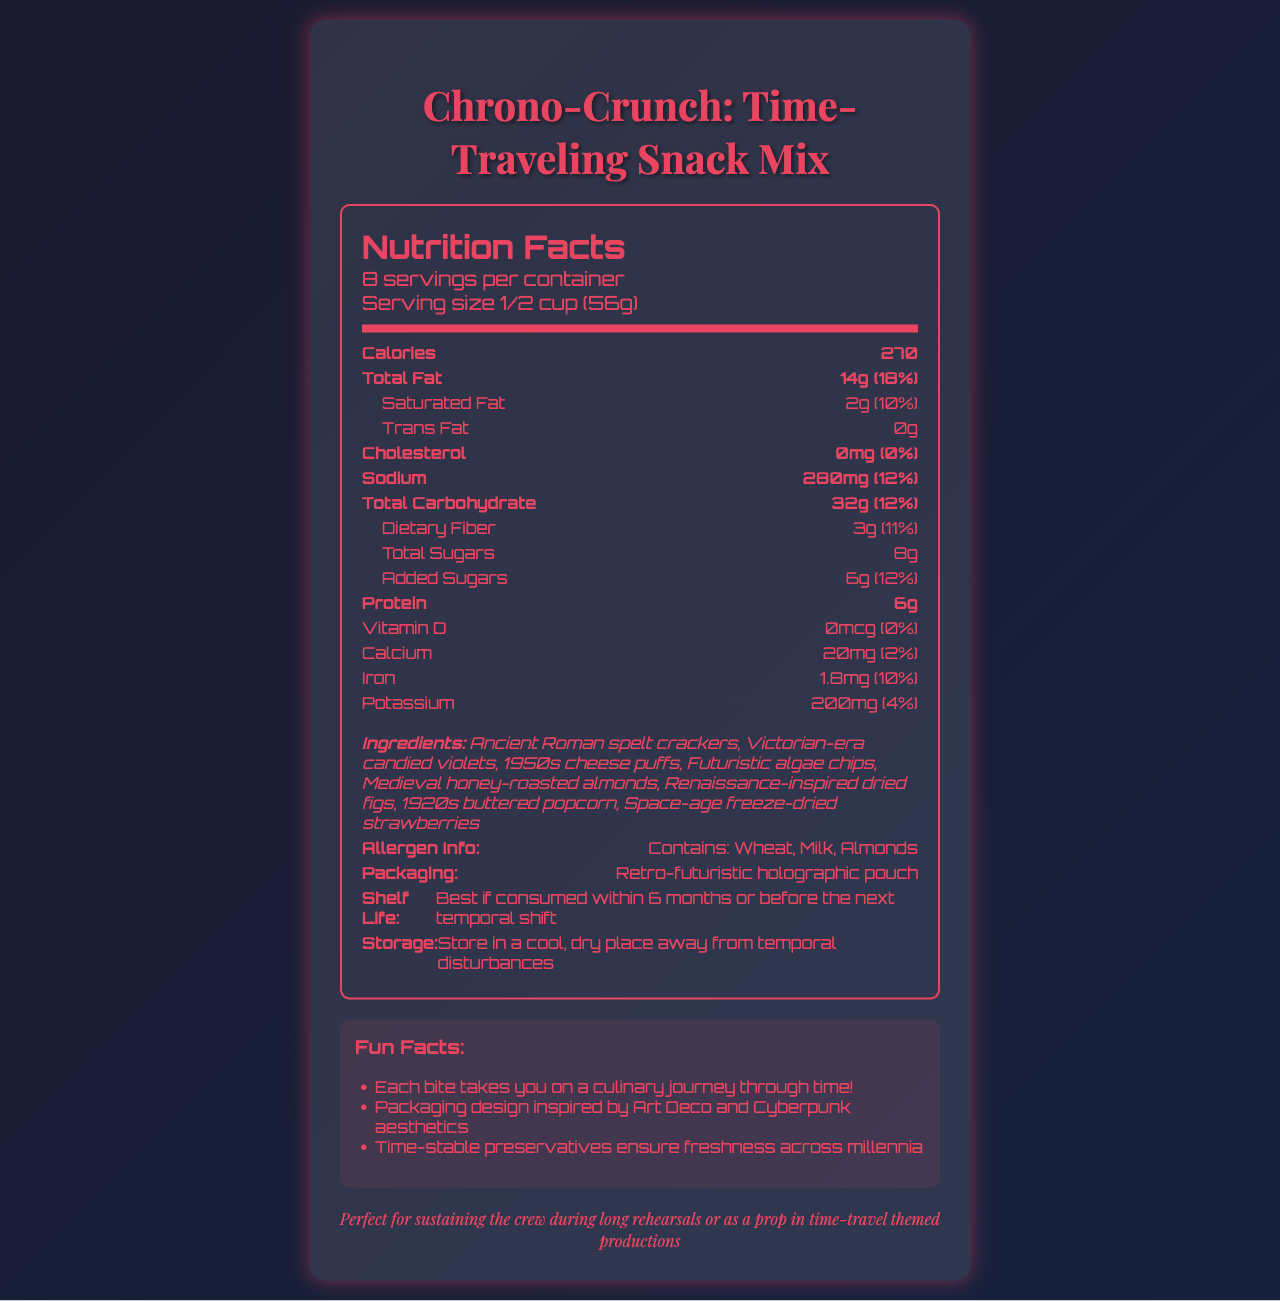what is the serving size? The serving size is explicitly stated in the nutrition label under the serving size section.
Answer: 1/2 cup (56g) how many servings are in the container? The document specifies that there are 8 servings per container.
Answer: 8 how many calories are in one serving? The number of calories per serving is listed in the nutrition facts.
Answer: 270 what is the total fat content per serving? The total fat content per serving is indicated as 14g in the nutrition label.
Answer: 14g how much protein is in one serving? The amount of protein per serving is noted in the nutrition facts label as 6g.
Answer: 6g which allergens are present in the snack mix? A. Wheat B. Milk and Almonds C. Both A and B D. None The allergen info section states that the product contains Wheat, Milk, and Almonds.
Answer: C which era is NOT represented in the list of ingredients? 1. Medieval 2. Renaissance 3. Victorian 4. Modern-day The ingredients list does not include any modern-day items. Mentioned eras are Ancient Roman, Victorian, 1950s, Futuristic, Medieval, Renaissance, 1920s, and Space-age.
Answer: 4 is there any cholesterol in the product? The nutrition facts specify that the product contains 0mg cholesterol, 0% daily value.
Answer: No describe the overall theme and design of the document. The document is visually designed with a blend of futuristic and retro styles, offering detailed nutritional information and creatively listing ingredients from different historical periods. It also provides packaging and storage information, as well as a theatrical note about its potential use in time-travel themed productions.
Answer: The document features a creative nutrition label for "Chrono-Crunch: Time-Traveling Snack Mix", designed with a mix of retro and futuristic aesthetics. It includes detailed nutritional information, a fun list of ingredients from various historical eras, allergen info, packaging details, storage instructions, and additional fun facts. The design incorporates Art Deco and Cyberpunk elements, making it visually appealing and thematically appropriate for time-travel. who is the manufacturer of Chrono-Crunch? The document does not provide any information about the manufacturer of Chrono-Crunch.
Answer: Not enough information how many grams of dietary fiber does one serving contain? The nutritional details in the document show that one serving contains 3g of dietary fiber.
Answer: 3g what is the daily value percentage for iron in one serving? The document specifies that one serving provides 10% of the daily value for iron.
Answer: 10% what feature of the packaging design is highlighted in the document? The packaging section clearly states that the snack mix is packaged in a retro-futuristic holographic pouch.
Answer: Retro-futuristic holographic pouch how should the snack mix be stored to maintain its quality? The storage instructions advise keeping the product in a cool, dry place away from temporal disturbances.
Answer: Store in a cool, dry place away from temporal disturbances what percentage of the daily value of saturated fat is in one serving? The document mentions that one serving contains 2g of saturated fat, which is 10% of the daily value.
Answer: 10% is there any Vitamin D in the snack mix? According to the nutritional information, there is 0mcg of Vitamin D in the snack mix.
Answer: No 